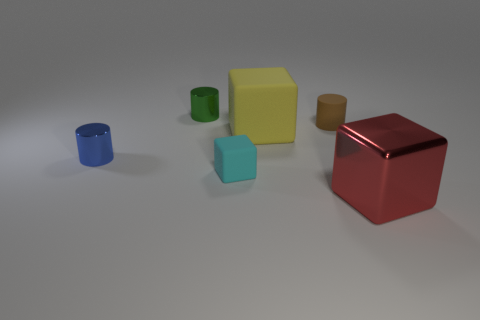Add 2 small red rubber balls. How many objects exist? 8 Add 2 yellow blocks. How many yellow blocks are left? 3 Add 5 green balls. How many green balls exist? 5 Subtract 0 gray cubes. How many objects are left? 6 Subtract all brown matte cylinders. Subtract all small yellow shiny spheres. How many objects are left? 5 